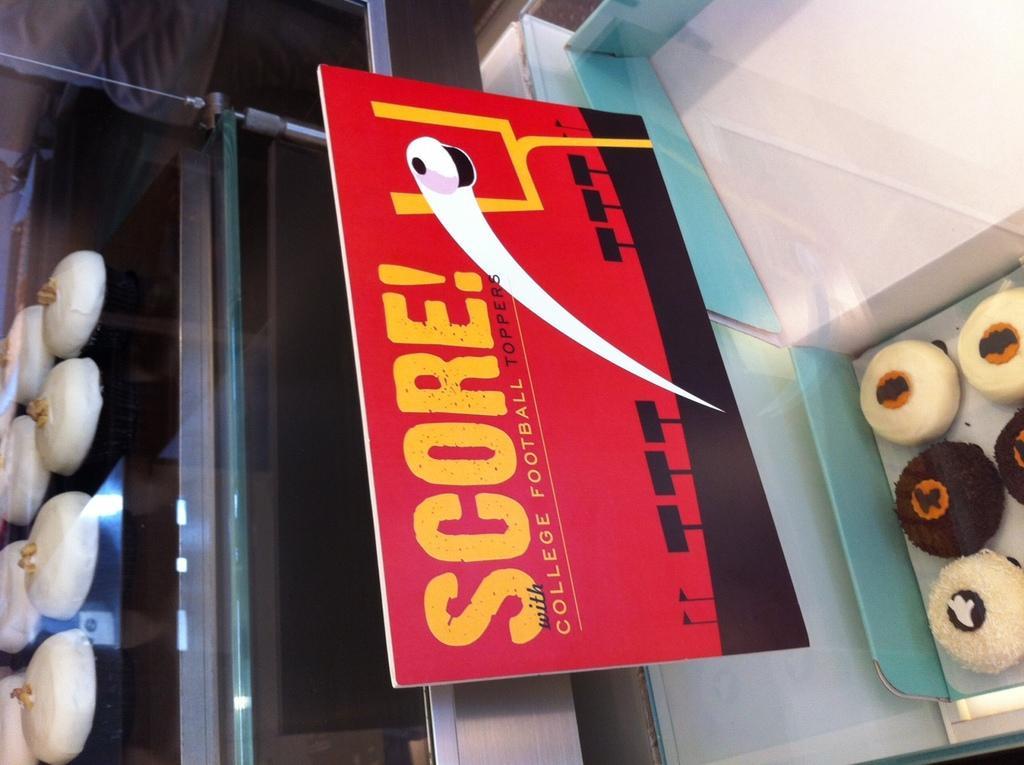Can you describe this image briefly? In this image, we can see deserts in the box and we can see a board and in the background, there is a person and we can see some other deserts on the stand. 